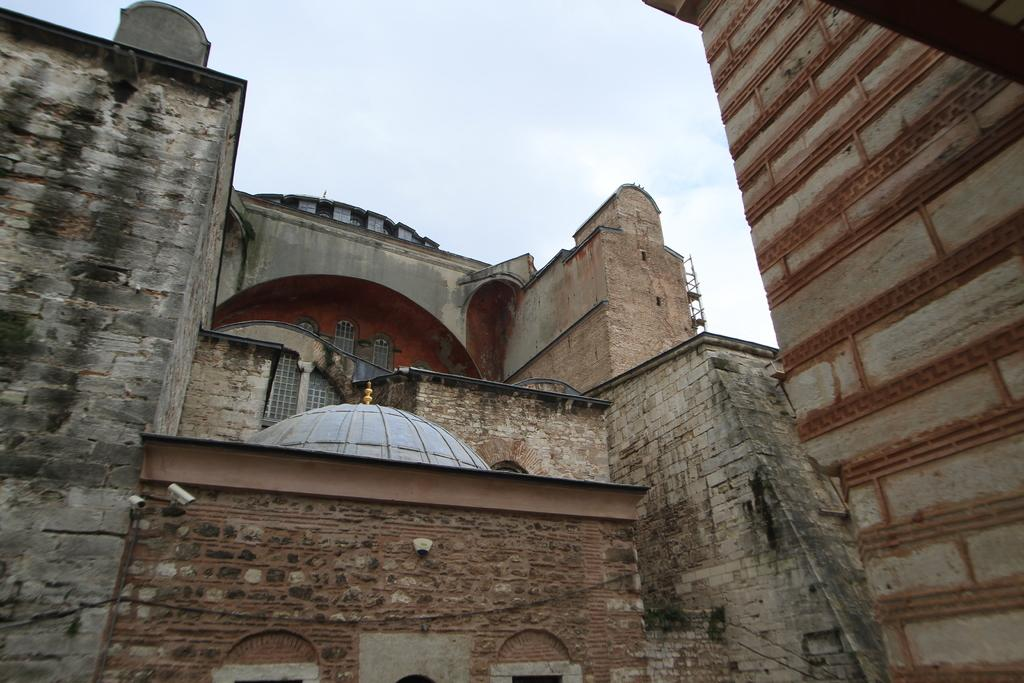What type of structures are present in the image? There are buildings in the image. What colors can be seen on the buildings? The buildings have cream, brown, black, and orange colors. What features are present on the buildings? The buildings have roofs and windows. What can be seen in the background of the image? The sky is visible in the background of the image. Can you see a crown on top of any of the buildings in the image? There is no crown present on any of the buildings in the image. Are there any geese flying in the sky in the image? There are no geese visible in the sky in the image. 